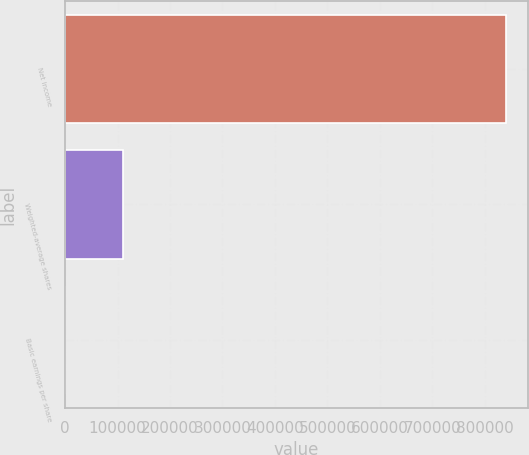<chart> <loc_0><loc_0><loc_500><loc_500><bar_chart><fcel>Net income<fcel>Weighted-average shares<fcel>Basic earnings per share<nl><fcel>839189<fcel>111173<fcel>7.55<nl></chart> 